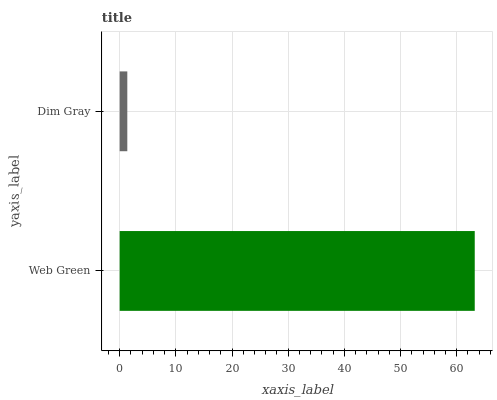Is Dim Gray the minimum?
Answer yes or no. Yes. Is Web Green the maximum?
Answer yes or no. Yes. Is Dim Gray the maximum?
Answer yes or no. No. Is Web Green greater than Dim Gray?
Answer yes or no. Yes. Is Dim Gray less than Web Green?
Answer yes or no. Yes. Is Dim Gray greater than Web Green?
Answer yes or no. No. Is Web Green less than Dim Gray?
Answer yes or no. No. Is Web Green the high median?
Answer yes or no. Yes. Is Dim Gray the low median?
Answer yes or no. Yes. Is Dim Gray the high median?
Answer yes or no. No. Is Web Green the low median?
Answer yes or no. No. 